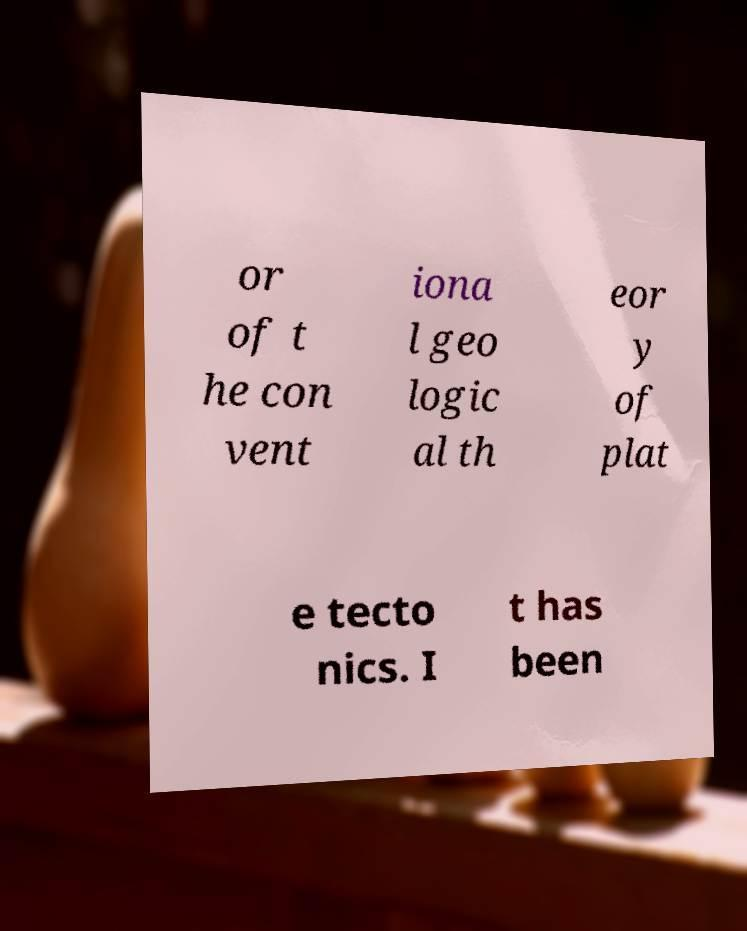What messages or text are displayed in this image? I need them in a readable, typed format. or of t he con vent iona l geo logic al th eor y of plat e tecto nics. I t has been 